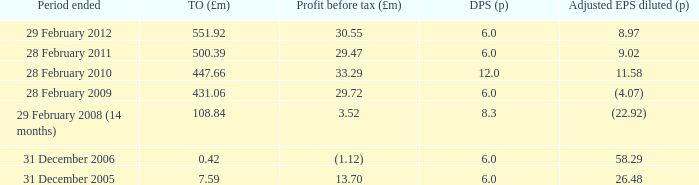What was the profit before tax when the turnover was 431.06? 29.72. 